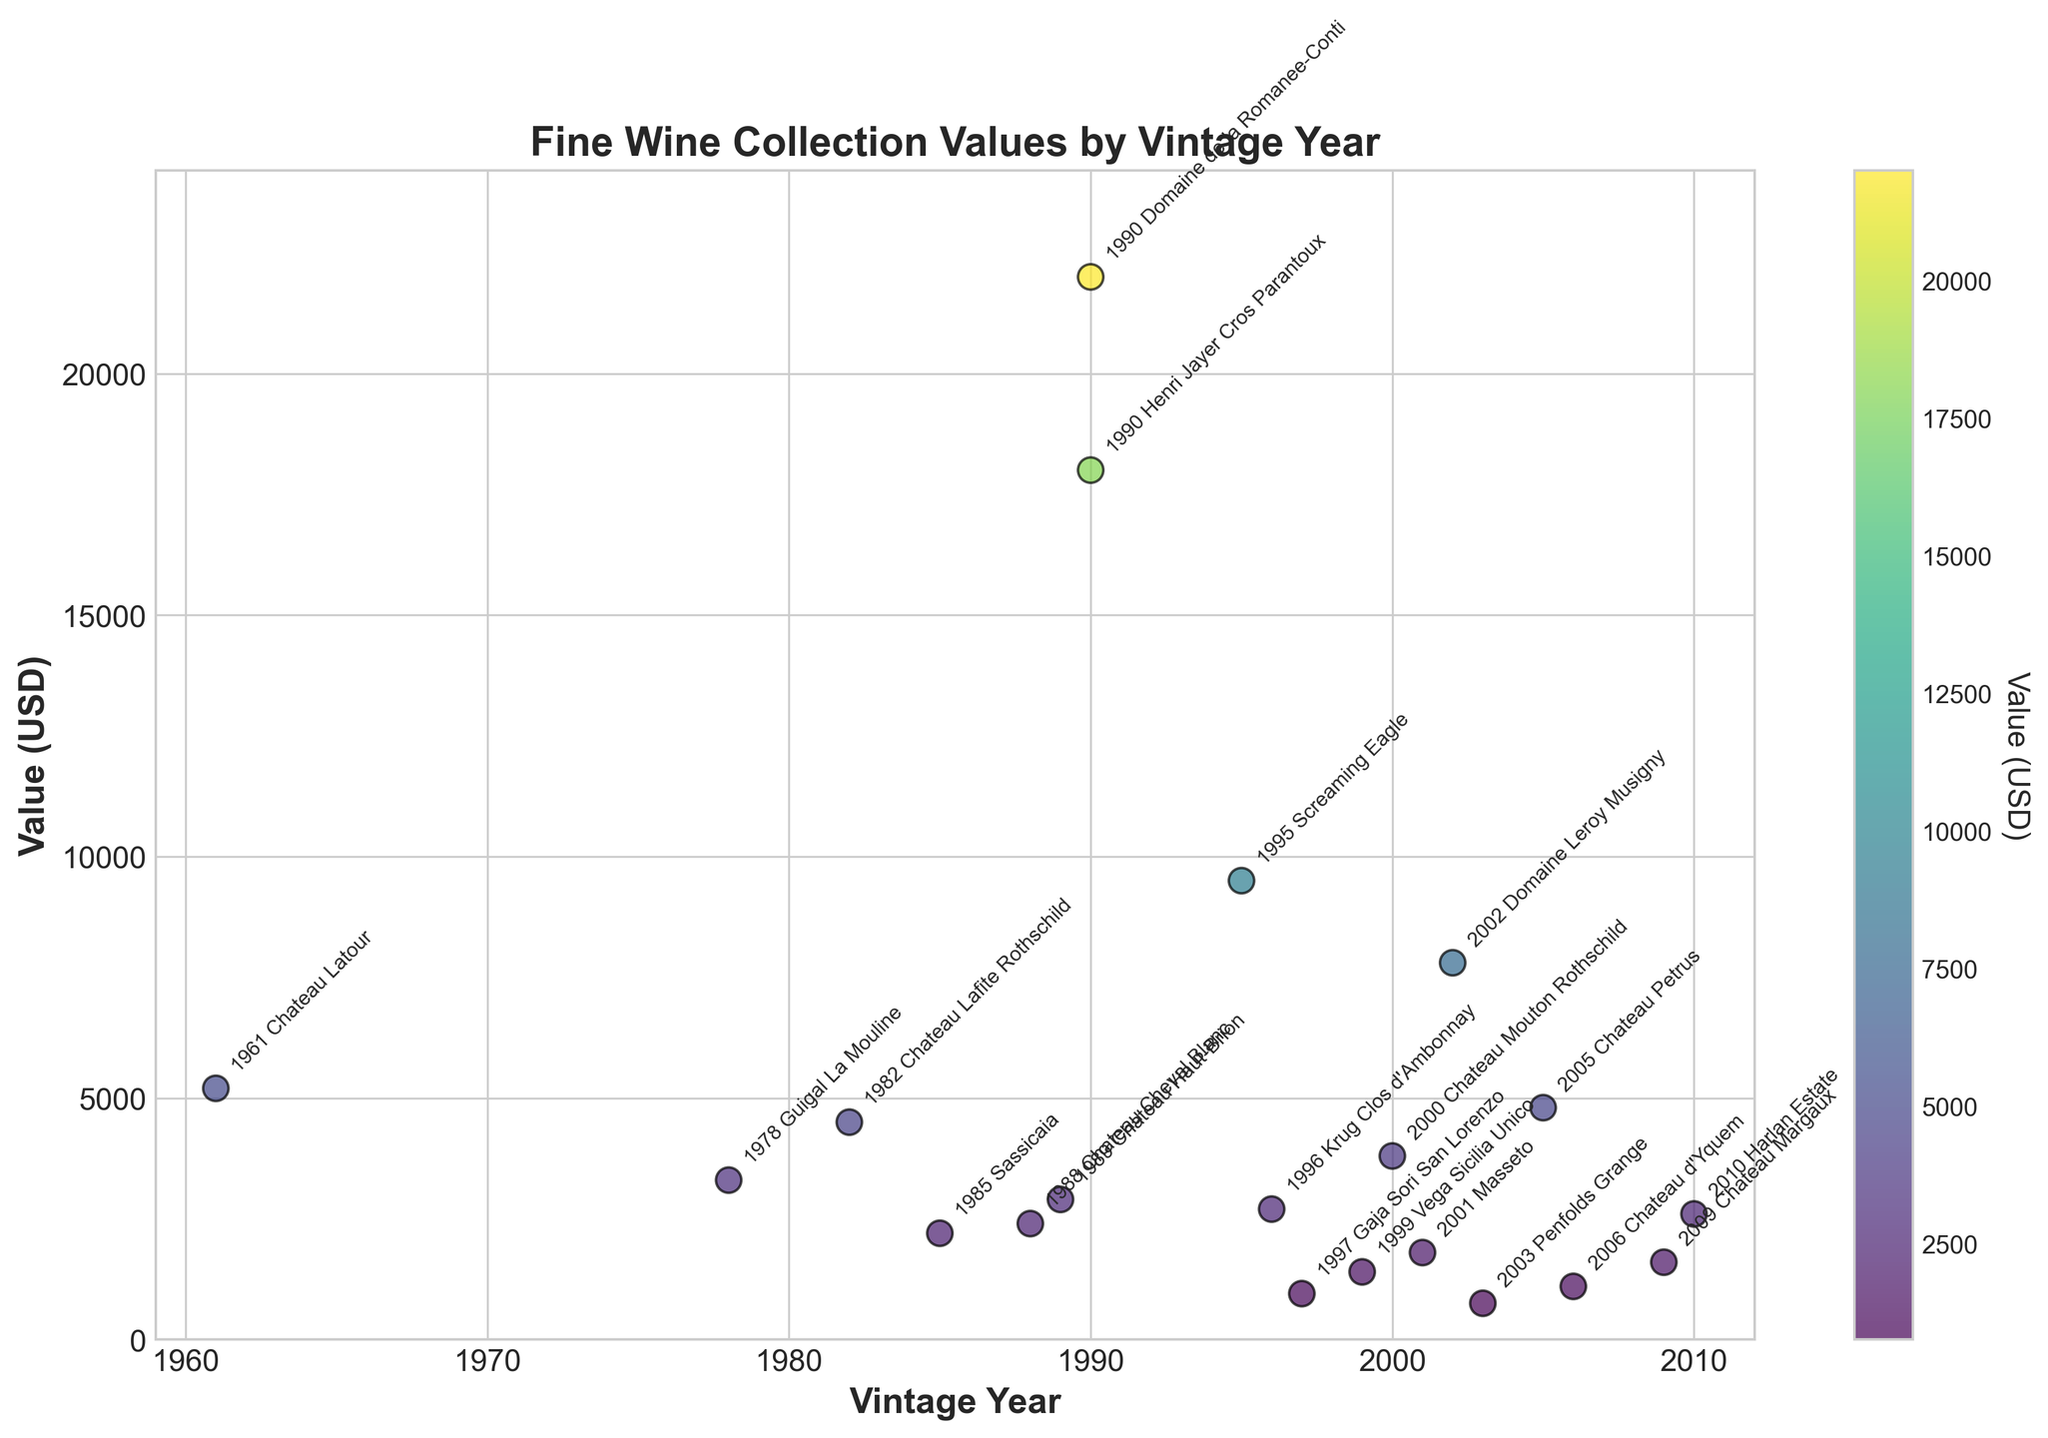Which vintage year has the highest value? Look at the scatter plot and identify the data point with the highest y-value. The highest value on the y-axis is $22,000, corresponding to the vintage year 1990.
Answer: 1990 What is the range of values for the wines? The range is calculated by subtracting the minimum value from the maximum value in the data set. The minimum value is $750 and the maximum is $22,000. Therefore, the range is $22,000 - $750.
Answer: $21,250 How many wines are valued at $5000 or above? Count the number of points on the scatter plot that are at or above the $5000 mark on the y-axis. There are five points: $5200, $9500, $7800, $18000, and $22000.
Answer: 5 Which vintage year has the lowest value? Look at the scatter plot and identify the data point with the lowest y-value. The lowest value on the y-axis is $750, corresponding to the vintage year 2003.
Answer: 2003 What is the average value of the wines from the 1990s? Identify the data points for the 1990s (1990, 1995, 1996, 1997, 1999) and calculate the average of their values. The values are $22,000, $9500, $2700, $950, $1400. The average is calculated as ($22,000 + $9500 + $2700 + $950 + $1400) / 5.
Answer: $7270 Are there more wines valued above $10,000 or below $2000? Count the number of data points above $10,000 and below $2000. Data points above $10,000: 3. Data points below $2000: 4.
Answer: Below $2000 Which vintage year has the most clustered values around $2000? Observe the scatter plot and assess which vintage year has multiple data points near the $2000 mark on the y-axis. The year with wines classified around $2000 appears to be 1988 (with values $2200 and $2400).
Answer: 1988 What is the difference in value between the 1982 and 2000 vintages? Identify the values for the 1982 ($4500) and 2000 ($3800) vintages on the scatter plot and subtract the latter from the former: $4500 - $3800.
Answer: $700 